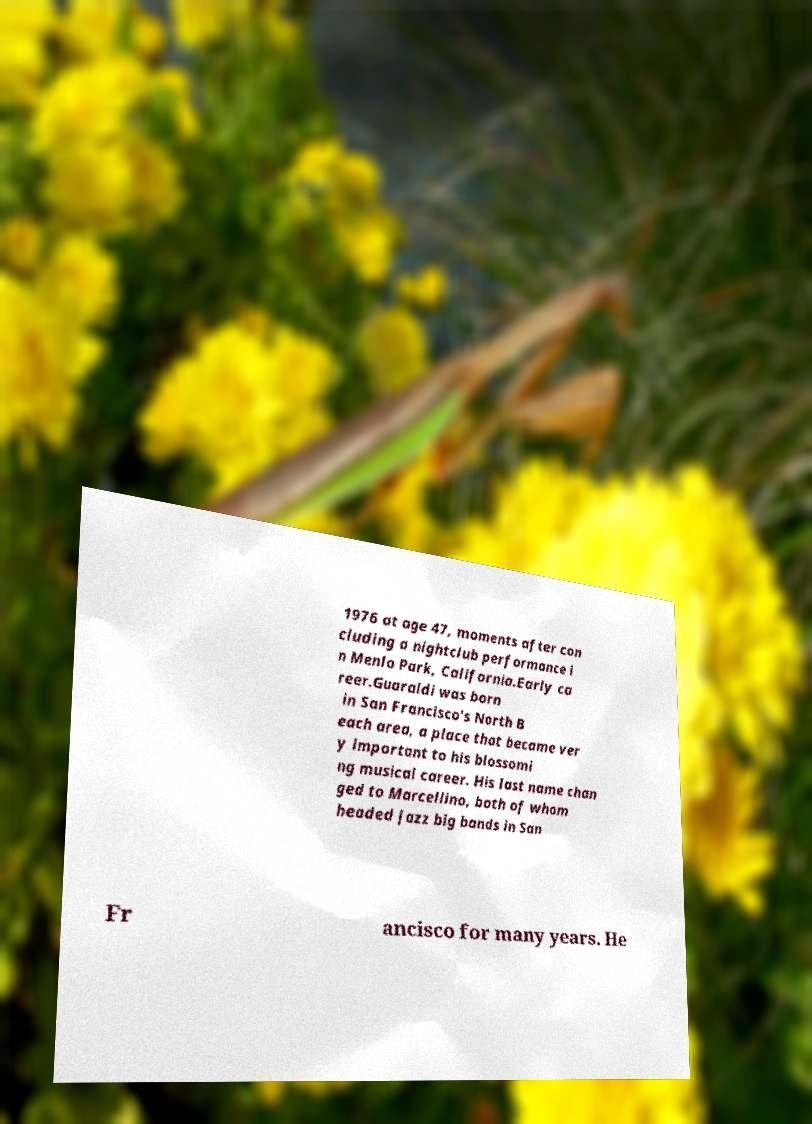Please read and relay the text visible in this image. What does it say? 1976 at age 47, moments after con cluding a nightclub performance i n Menlo Park, California.Early ca reer.Guaraldi was born in San Francisco's North B each area, a place that became ver y important to his blossomi ng musical career. His last name chan ged to Marcellino, both of whom headed jazz big bands in San Fr ancisco for many years. He 